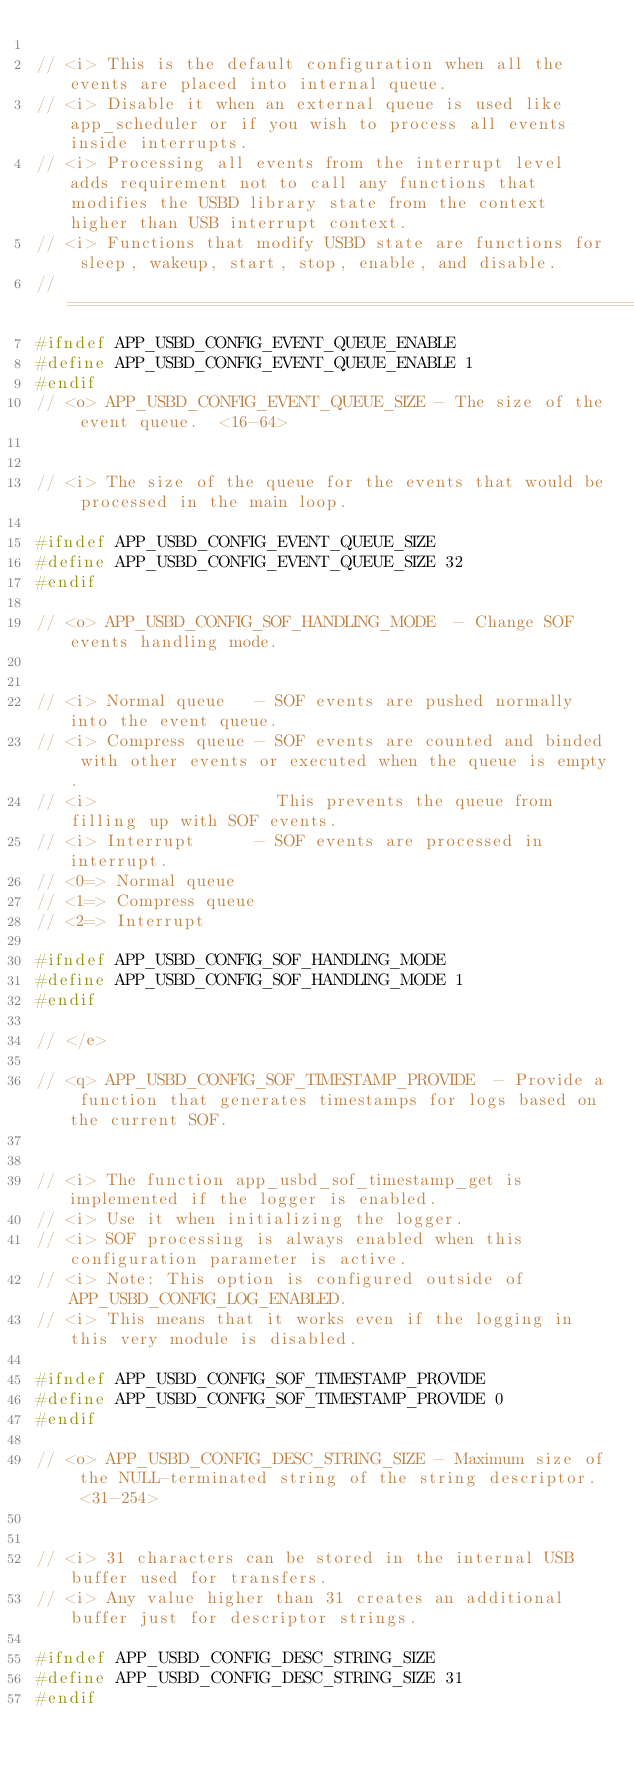<code> <loc_0><loc_0><loc_500><loc_500><_C_>
// <i> This is the default configuration when all the events are placed into internal queue.
// <i> Disable it when an external queue is used like app_scheduler or if you wish to process all events inside interrupts.
// <i> Processing all events from the interrupt level adds requirement not to call any functions that modifies the USBD library state from the context higher than USB interrupt context.
// <i> Functions that modify USBD state are functions for sleep, wakeup, start, stop, enable, and disable.
//==========================================================
#ifndef APP_USBD_CONFIG_EVENT_QUEUE_ENABLE
#define APP_USBD_CONFIG_EVENT_QUEUE_ENABLE 1
#endif
// <o> APP_USBD_CONFIG_EVENT_QUEUE_SIZE - The size of the event queue.  <16-64> 


// <i> The size of the queue for the events that would be processed in the main loop.

#ifndef APP_USBD_CONFIG_EVENT_QUEUE_SIZE
#define APP_USBD_CONFIG_EVENT_QUEUE_SIZE 32
#endif

// <o> APP_USBD_CONFIG_SOF_HANDLING_MODE  - Change SOF events handling mode.
 

// <i> Normal queue   - SOF events are pushed normally into the event queue.
// <i> Compress queue - SOF events are counted and binded with other events or executed when the queue is empty.
// <i>                  This prevents the queue from filling up with SOF events.
// <i> Interrupt      - SOF events are processed in interrupt.
// <0=> Normal queue 
// <1=> Compress queue 
// <2=> Interrupt 

#ifndef APP_USBD_CONFIG_SOF_HANDLING_MODE
#define APP_USBD_CONFIG_SOF_HANDLING_MODE 1
#endif

// </e>

// <q> APP_USBD_CONFIG_SOF_TIMESTAMP_PROVIDE  - Provide a function that generates timestamps for logs based on the current SOF.
 

// <i> The function app_usbd_sof_timestamp_get is implemented if the logger is enabled. 
// <i> Use it when initializing the logger. 
// <i> SOF processing is always enabled when this configuration parameter is active. 
// <i> Note: This option is configured outside of APP_USBD_CONFIG_LOG_ENABLED. 
// <i> This means that it works even if the logging in this very module is disabled. 

#ifndef APP_USBD_CONFIG_SOF_TIMESTAMP_PROVIDE
#define APP_USBD_CONFIG_SOF_TIMESTAMP_PROVIDE 0
#endif

// <o> APP_USBD_CONFIG_DESC_STRING_SIZE - Maximum size of the NULL-terminated string of the string descriptor.  <31-254> 


// <i> 31 characters can be stored in the internal USB buffer used for transfers.
// <i> Any value higher than 31 creates an additional buffer just for descriptor strings.

#ifndef APP_USBD_CONFIG_DESC_STRING_SIZE
#define APP_USBD_CONFIG_DESC_STRING_SIZE 31
#endif
</code> 